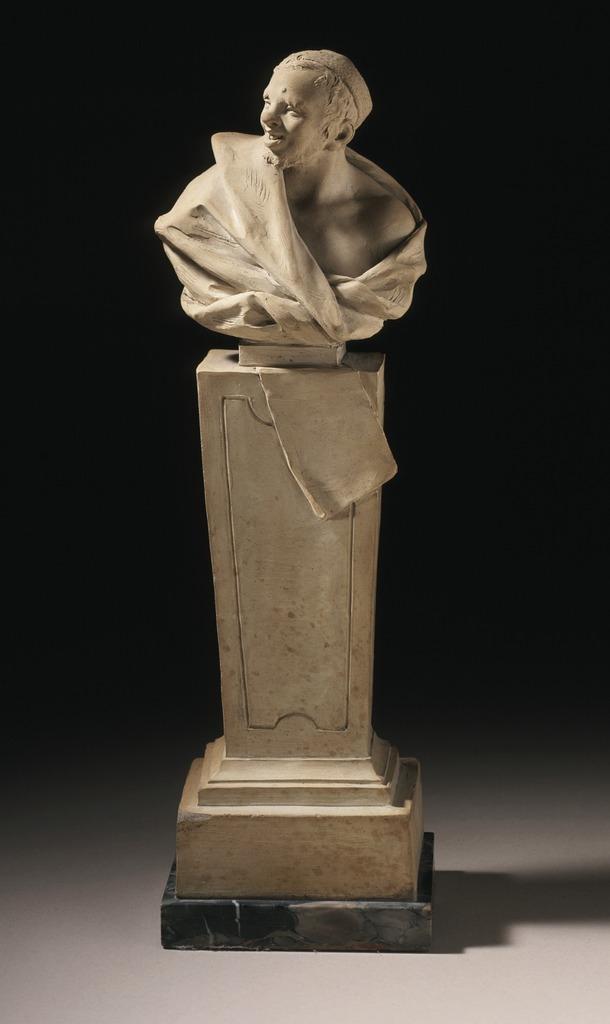Please provide a concise description of this image. In this image I can see a statue. The background is dark. 